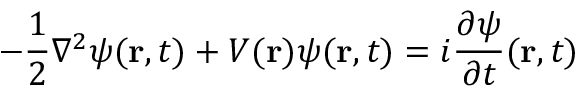<formula> <loc_0><loc_0><loc_500><loc_500>- { \frac { 1 } { 2 } } \nabla ^ { 2 } \psi ( r , t ) + V ( r ) \psi ( r , t ) = i { \frac { \partial \psi } { \partial t } } ( r , t )</formula> 